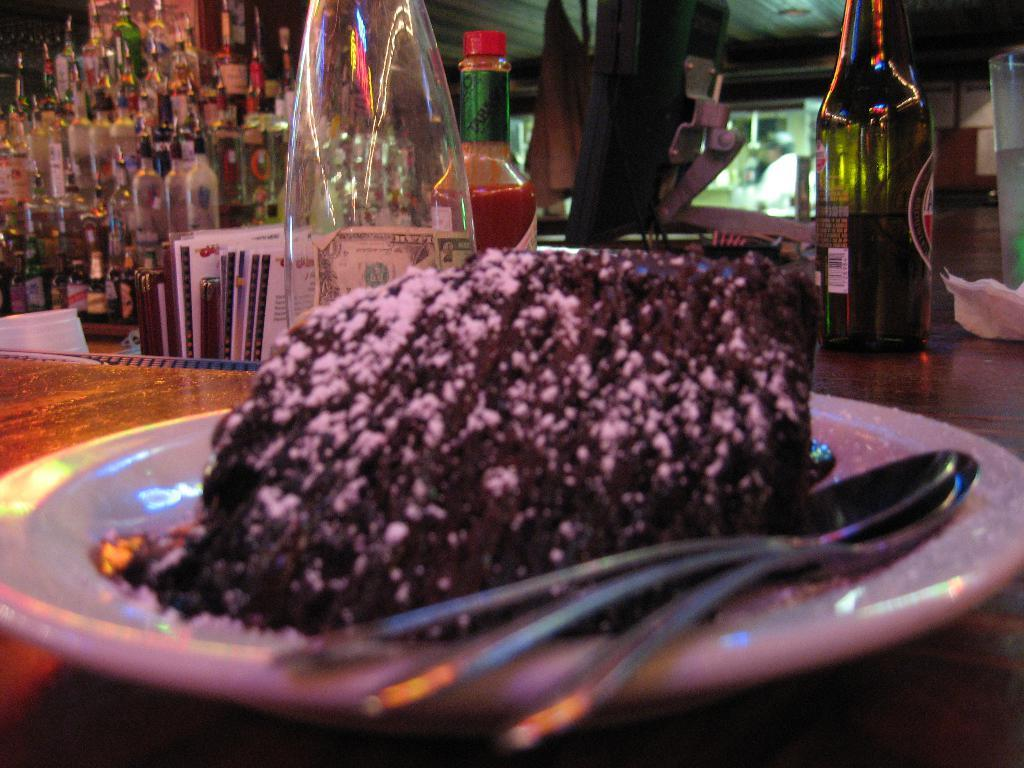What type of material is the wooden object in the image made of? The wooden object in the image is made of wood. What is placed on top of the wooden object? There is a plate on the wooden object. What is on the plate? The plate contains spoons and a food item. What can be seen behind the plate? There are bottles visible behind the plate, as well as other unspecified objects. What is the name of the bear that is sitting on the plate in the image? There are no bears present in the image; it features a wooden object, a plate with spoons and a food item, and bottles and other unspecified objects behind the plate. 